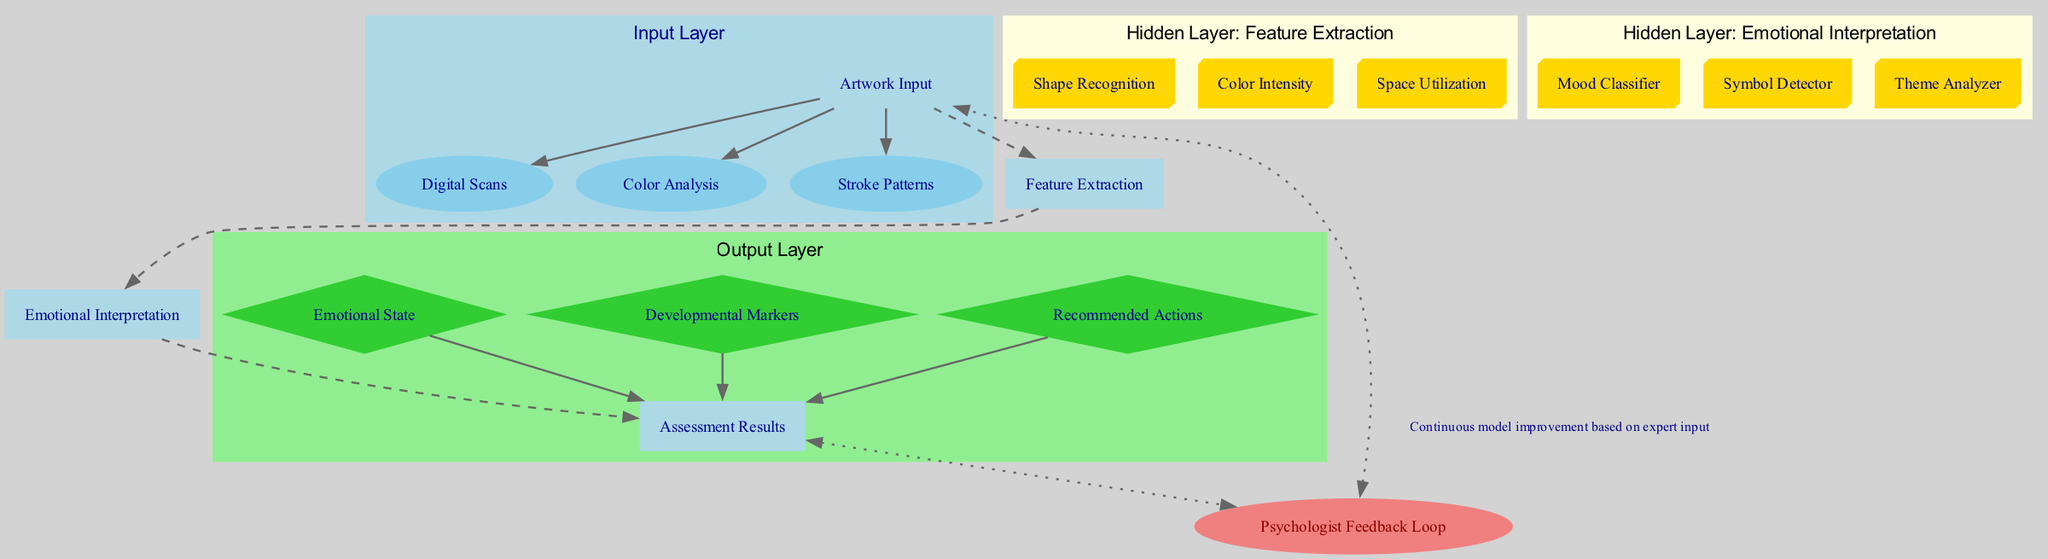What is the name of the input layer? The input layer is labeled as "Artwork Input" in the diagram, clearly indicating its purpose in the architecture.
Answer: Artwork Input How many hidden layers are there? The diagram includes two hidden layers: "Feature Extraction" and "Emotional Interpretation." We can count them directly in the diagram.
Answer: 2 What type of node is used for the output layer? The output layer is represented by a diamond-shaped node labeled "Assessment Results," which differentiates it from other layer types.
Answer: Diamond Which component is analyzed for color intensity? The "Color Intensity" node is a part of the "Feature Extraction" hidden layer, analyzing the emotional quality of the artwork based on color use.
Answer: Color Intensity What is the purpose of the feedback loop? The "Psychologist Feedback Loop" is designed for continuous improvement of the model based on expert input, allowing for refinement and accuracy over time.
Answer: Continuous model improvement From which layer does the "Mood Classifier" receive its input? The "Mood Classifier" receives input from the "Feature Extraction" layer, indicating it builds its analysis on the extracted features.
Answer: Feature Extraction What are the components of the output layer? The output layer consists of three components: "Emotional State," "Developmental Markers," and "Recommended Actions," summarizing the results of the analysis.
Answer: Emotional State, Developmental Markers, Recommended Actions Which hidden layer includes the "Symbol Detector"? The "Symbol Detector" is part of the "Emotional Interpretation" hidden layer, implying its role in identifying significant symbols related to the child's emotional state.
Answer: Emotional Interpretation How many nodes are in the "Feature Extraction" layer? The "Feature Extraction" layer contains three nodes: "Shape Recognition," "Color Intensity," and "Space Utilization," as indicated in the diagram.
Answer: 3 What color is used for the "Psychologist Feedback Loop" node? The "Psychologist Feedback Loop" node is colored light coral, which helps distinguish it visually from other elements in the diagram.
Answer: Light Coral 